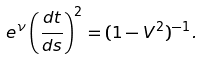Convert formula to latex. <formula><loc_0><loc_0><loc_500><loc_500>e ^ { \nu } \left ( \frac { d t } { d s } \right ) ^ { 2 } = ( 1 - V ^ { 2 } ) ^ { - 1 } .</formula> 